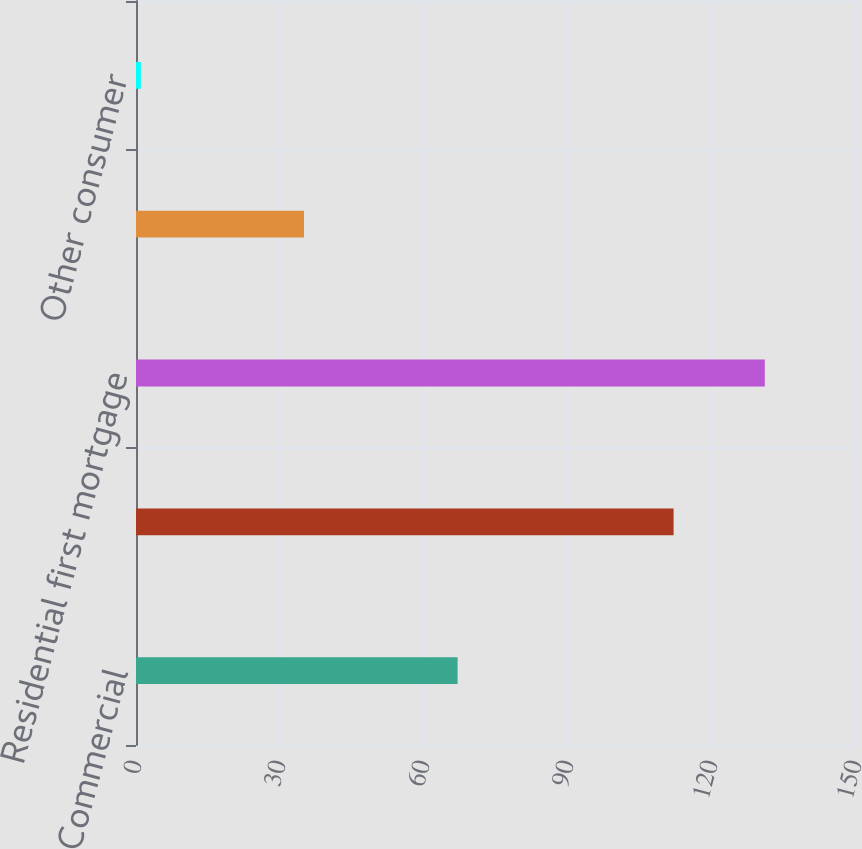Convert chart. <chart><loc_0><loc_0><loc_500><loc_500><bar_chart><fcel>Commercial<fcel>Investor real estate<fcel>Residential first mortgage<fcel>Home equity<fcel>Other consumer<nl><fcel>67<fcel>112<fcel>131<fcel>35<fcel>1<nl></chart> 